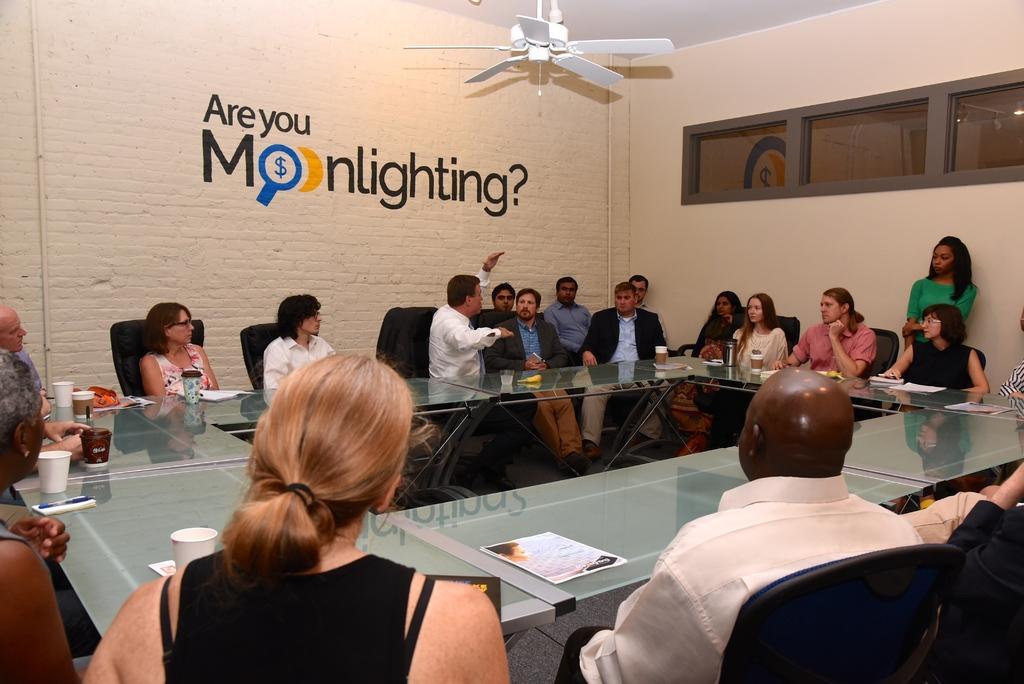In one or two sentences, can you explain what this image depicts? In this picture we can see a group of people sitting on chair in front of a glass table, here a man explaining something to people behind him, there is a paper on the table we can see some crops on the table, in the background we can see a brick wall and there is a fan on the ceiling, on the right side of the picture we can see a glass. 